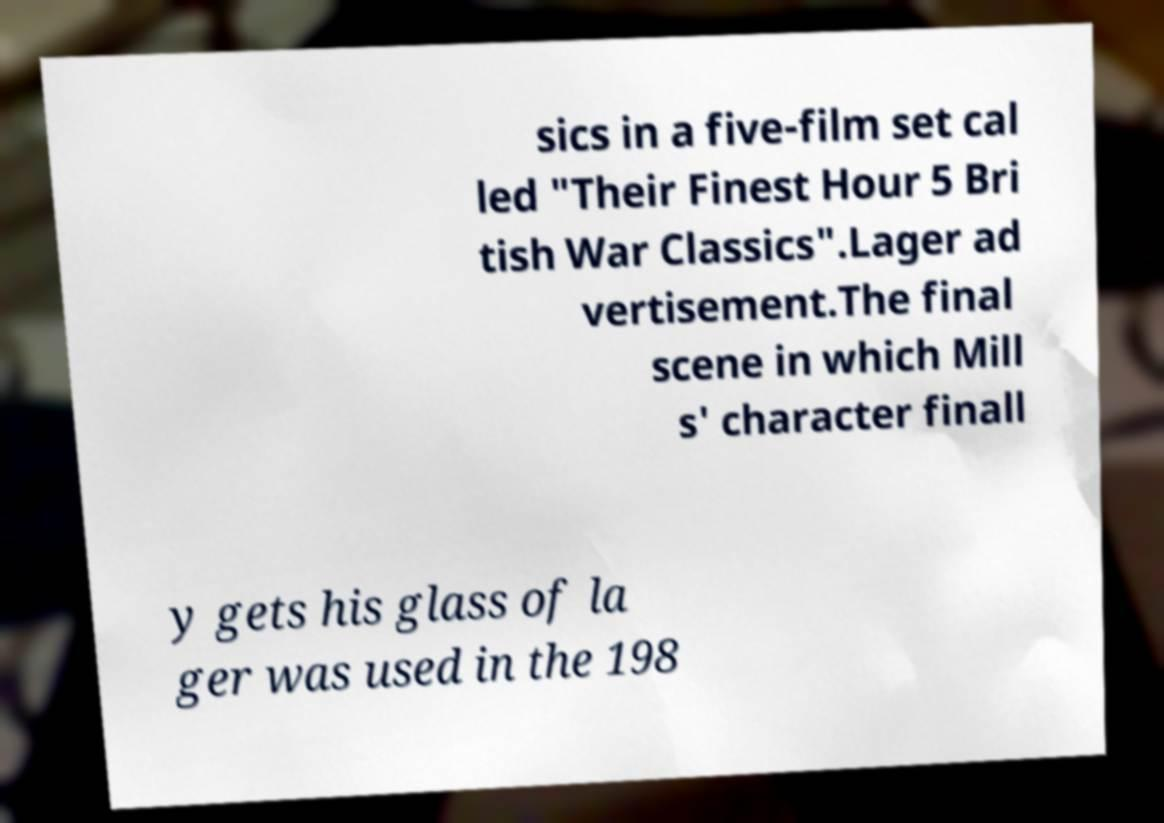Could you extract and type out the text from this image? sics in a five-film set cal led "Their Finest Hour 5 Bri tish War Classics".Lager ad vertisement.The final scene in which Mill s' character finall y gets his glass of la ger was used in the 198 